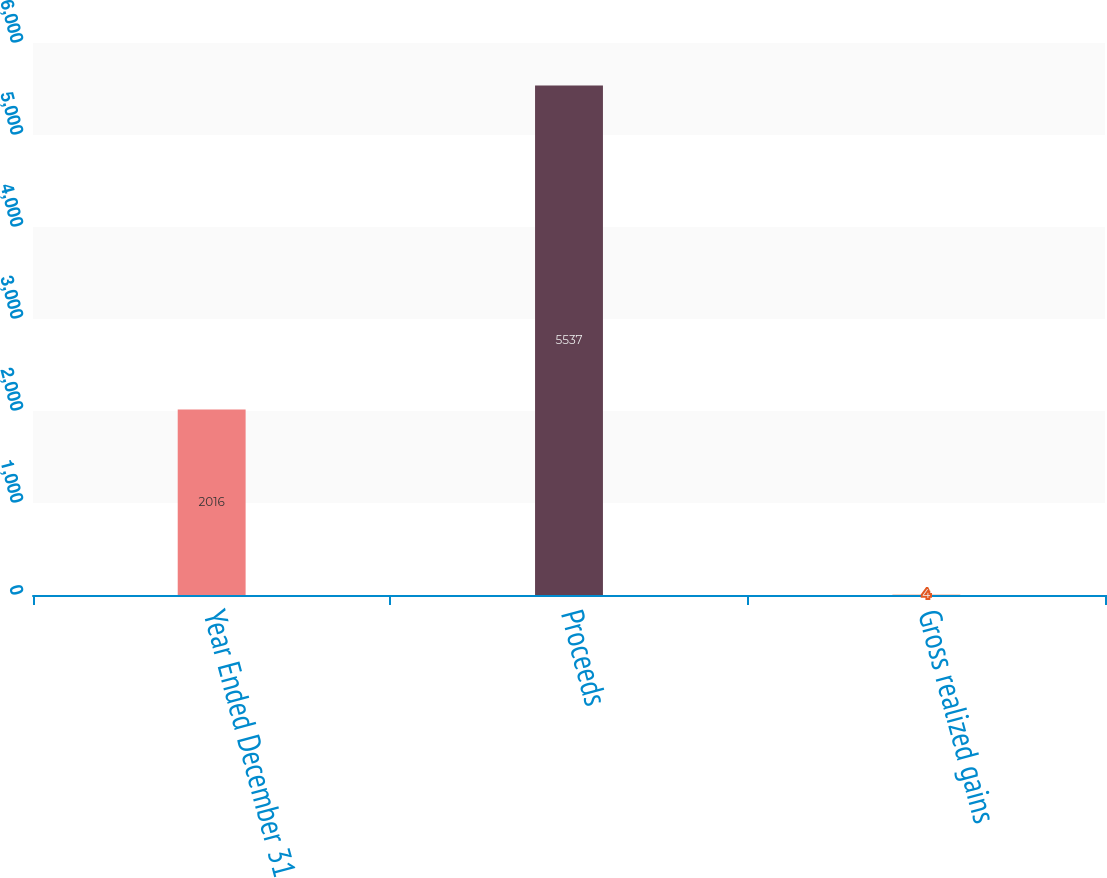Convert chart. <chart><loc_0><loc_0><loc_500><loc_500><bar_chart><fcel>Year Ended December 31<fcel>Proceeds<fcel>Gross realized gains<nl><fcel>2016<fcel>5537<fcel>4<nl></chart> 